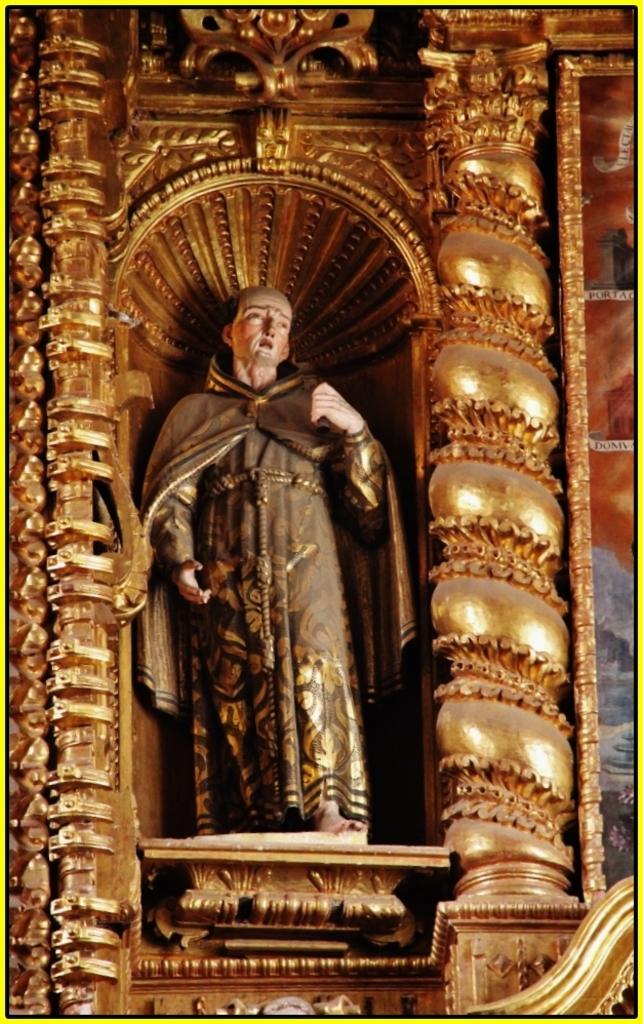Could you give a brief overview of what you see in this image? This looks like a sculpture of the man. This is the architecture, which is gold in color. 